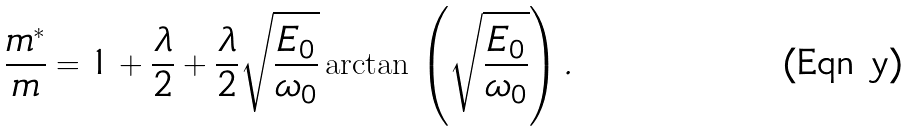<formula> <loc_0><loc_0><loc_500><loc_500>\frac { m ^ { * } } { m } = 1 + \frac { \lambda } { 2 } + \frac { \lambda } { 2 } \sqrt { \frac { E _ { 0 } } { \omega _ { 0 } } } \arctan \, \left ( \sqrt { \frac { E _ { 0 } } { \omega _ { 0 } } } \right ) .</formula> 